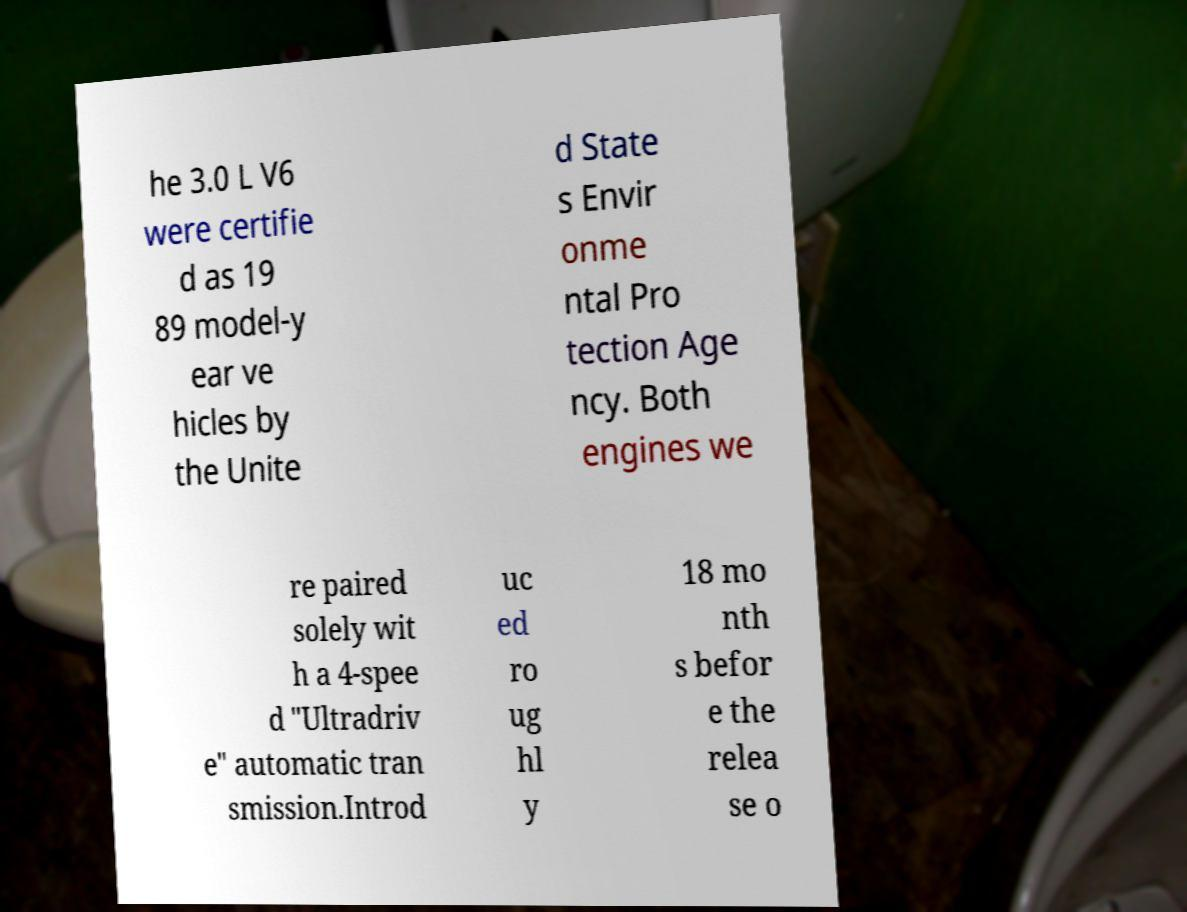For documentation purposes, I need the text within this image transcribed. Could you provide that? he 3.0 L V6 were certifie d as 19 89 model-y ear ve hicles by the Unite d State s Envir onme ntal Pro tection Age ncy. Both engines we re paired solely wit h a 4-spee d "Ultradriv e" automatic tran smission.Introd uc ed ro ug hl y 18 mo nth s befor e the relea se o 